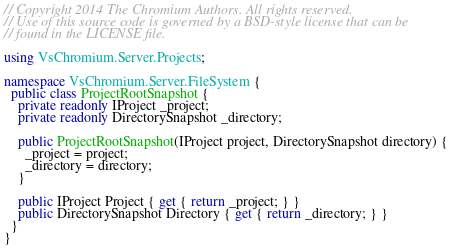Convert code to text. <code><loc_0><loc_0><loc_500><loc_500><_C#_>// Copyright 2014 The Chromium Authors. All rights reserved.
// Use of this source code is governed by a BSD-style license that can be
// found in the LICENSE file.

using VsChromium.Server.Projects;

namespace VsChromium.Server.FileSystem {
  public class ProjectRootSnapshot {
    private readonly IProject _project;
    private readonly DirectorySnapshot _directory;

    public ProjectRootSnapshot(IProject project, DirectorySnapshot directory) {
      _project = project;
      _directory = directory;
    }

    public IProject Project { get { return _project; } }
    public DirectorySnapshot Directory { get { return _directory; } }
  }
}</code> 